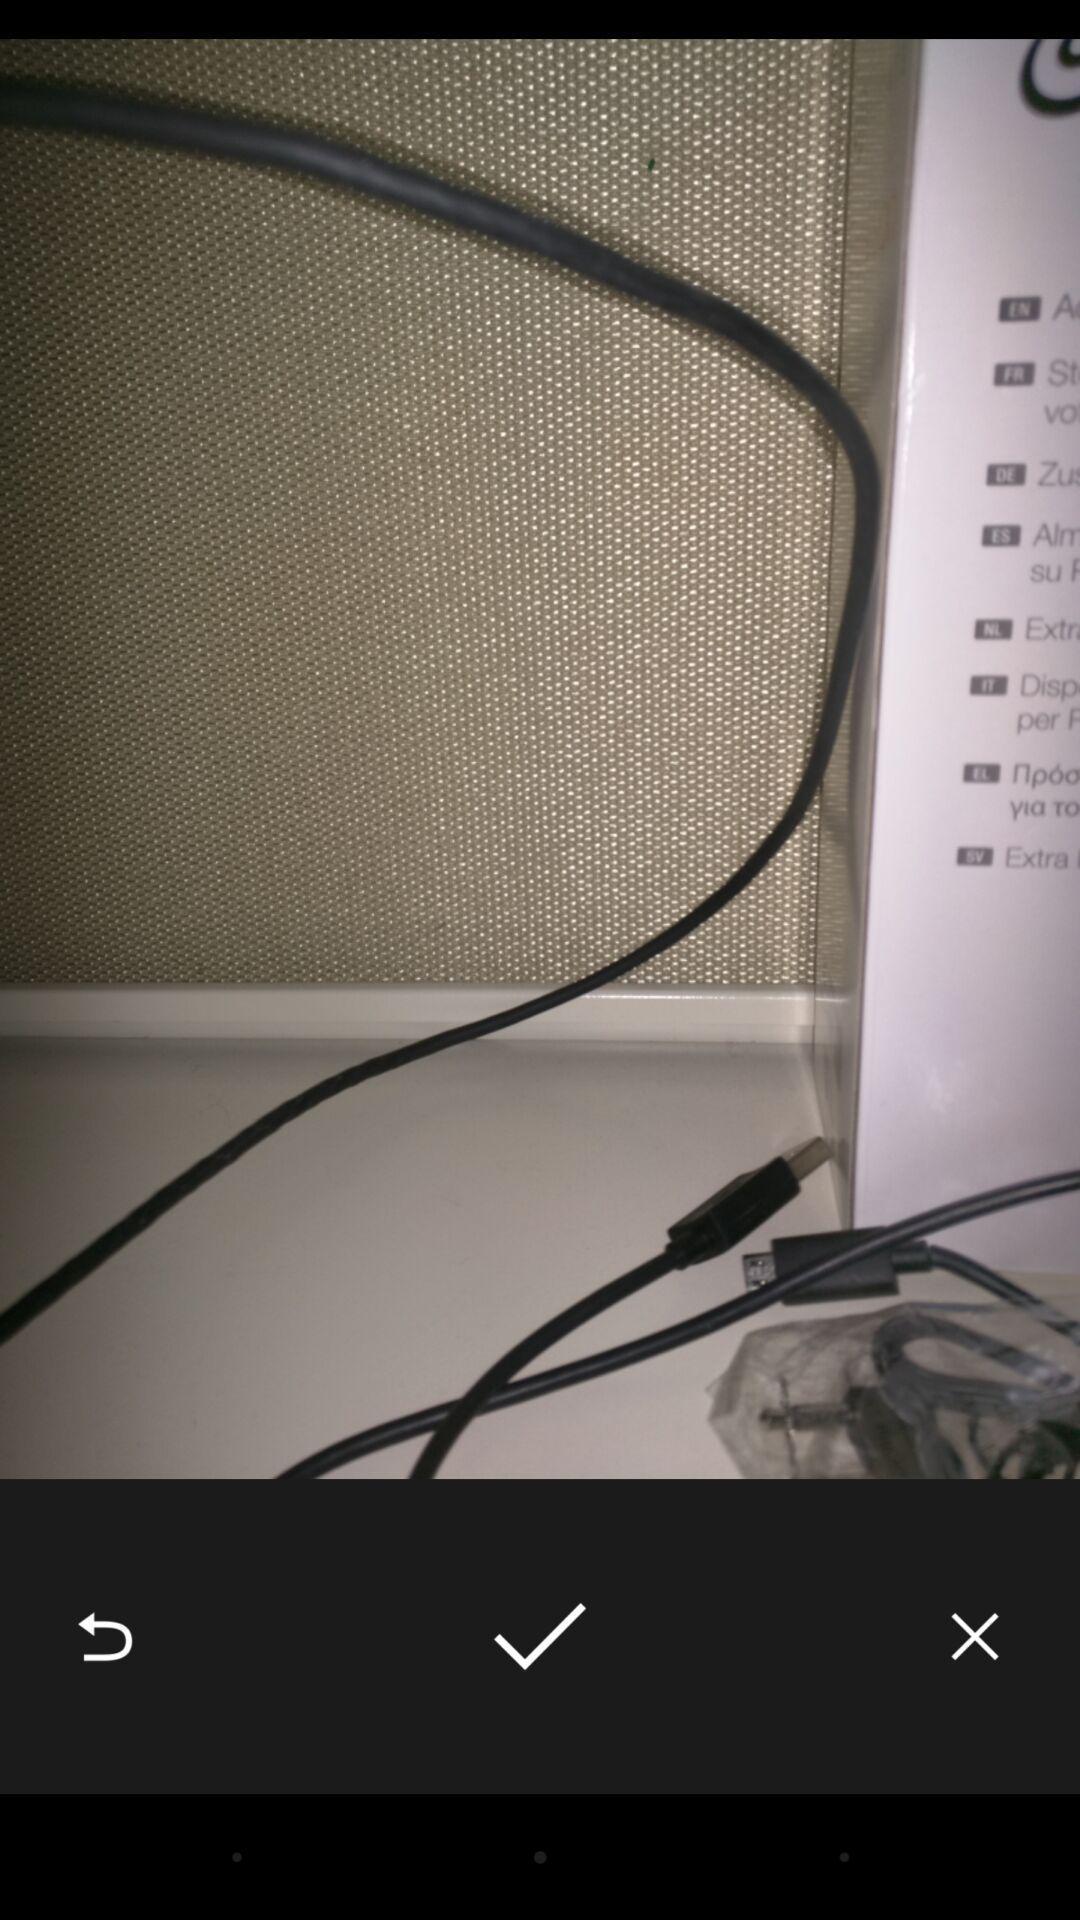Describe the key features of this screenshot. Screen displaying the image with select options. 